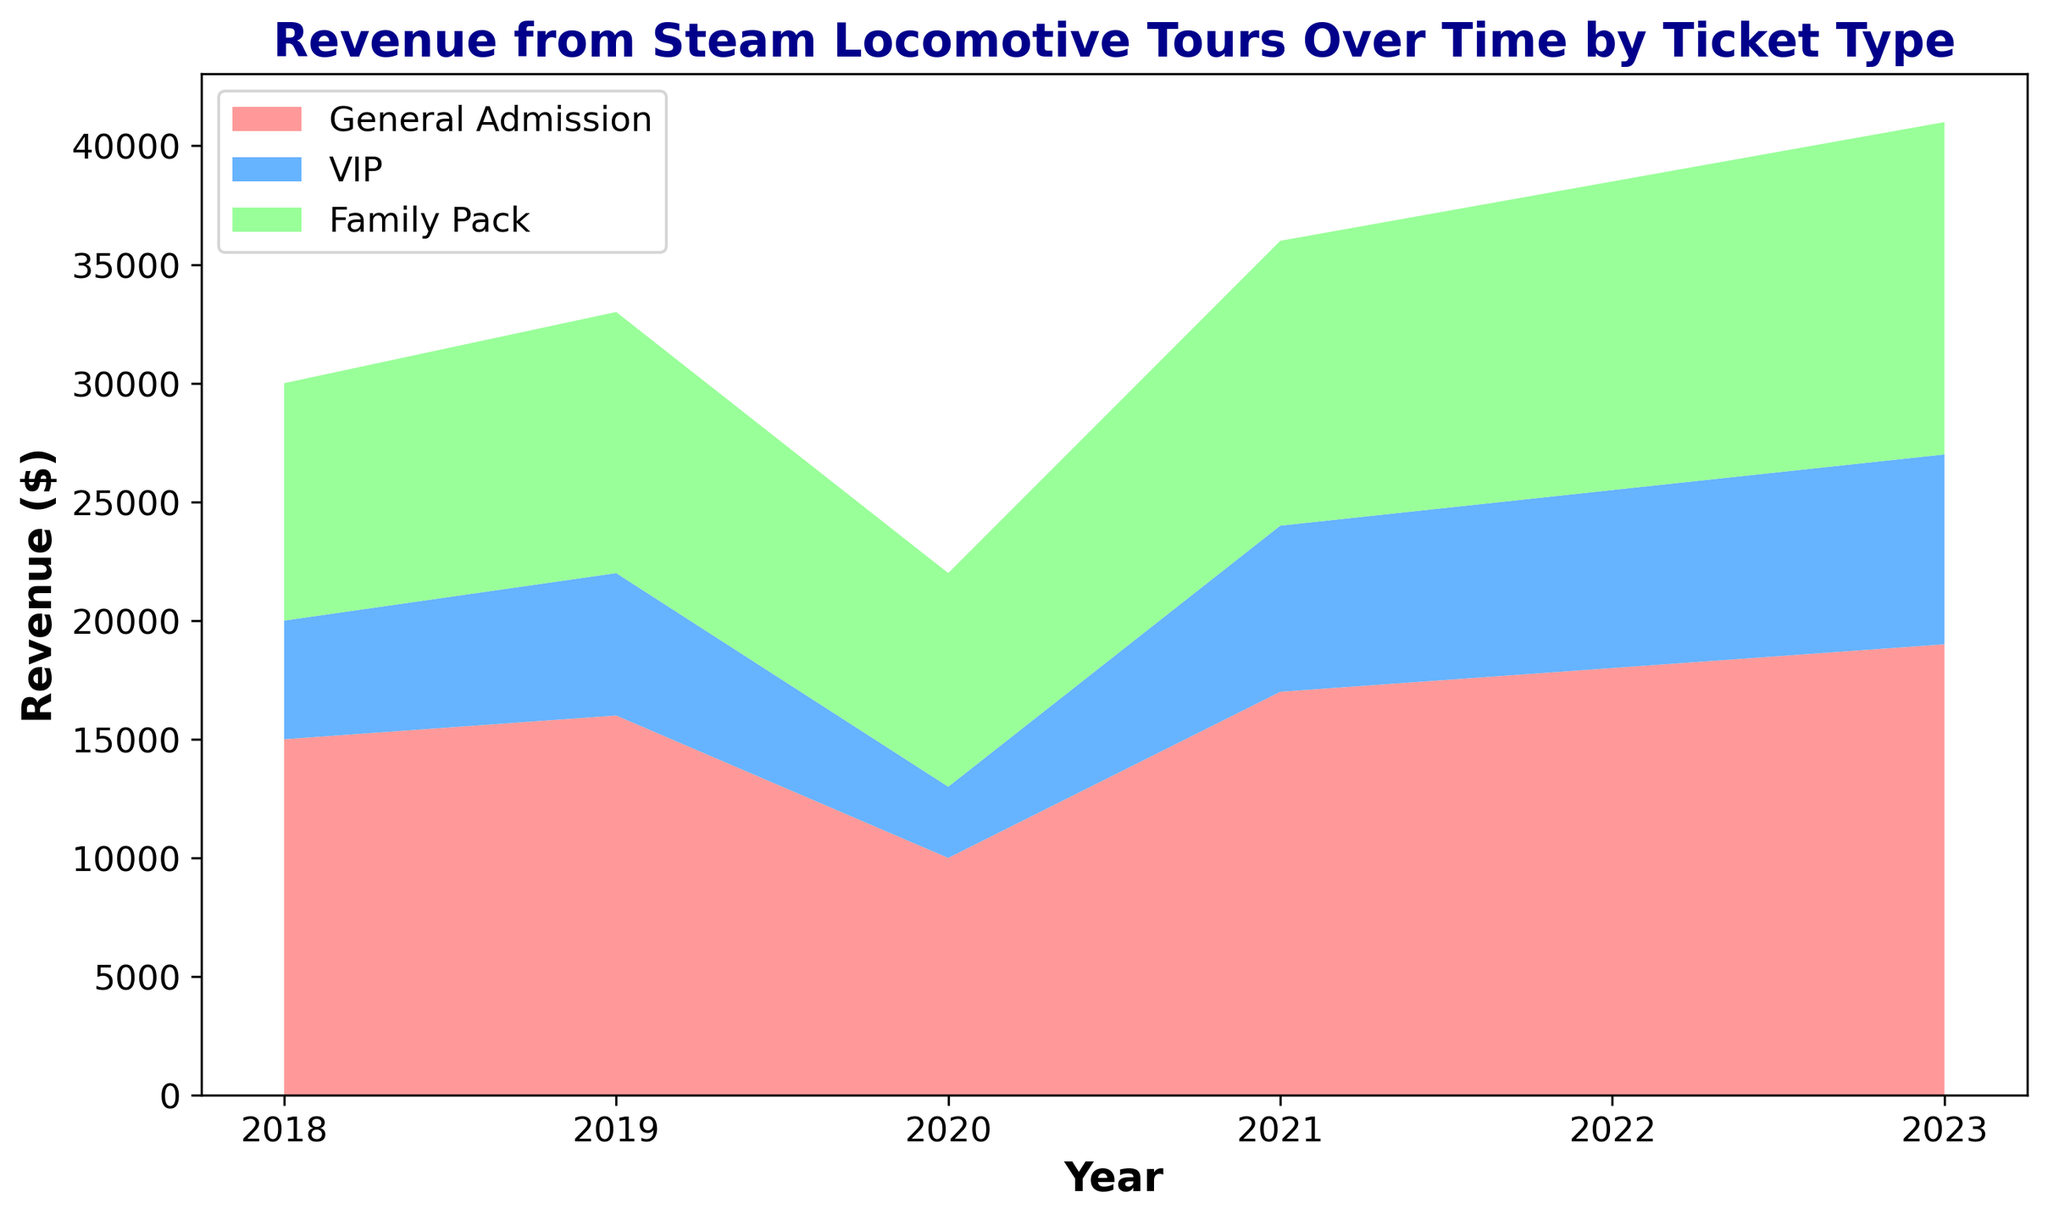What year had the highest revenue from General Admission tickets? The chart shows the revenue from General Admission tickets over the years. The highest point is in 2023.
Answer: 2023 How much more revenue did VIP tickets generate in 2023 compared to 2020? In 2023, VIP tickets generated $8000, and in 2020, they generated $3000. The difference is $8000 - $3000 = $5000.
Answer: $5000 Compare the Family Pack ticket revenues in 2018 and 2022. Which year had a higher revenue, and by how much? In 2018, the Family Pack revenue was $10000, and in 2022, it was $13000. The difference is $13000 - $10000 = $3000.
Answer: 2022, by $3000 Which ticket type showed the most significant increase in revenue from 2019 to 2021? The revenues for each ticket type from 2019 to 2021 are as follows: General Admission increased from $16000 to $17000 ($1000 increase), VIP increased from $6000 to $7000 ($1000 increase), and Family Pack increased from $11000 to $12000 ($1000 increase). Each ticket type showed the same increase of $1000.
Answer: All had the same increase of $1000 What's the total revenue from all ticket types in 2023? Sum the revenues from all ticket types in 2023: General Admission ($19000) + VIP ($8000) + Family Pack ($14000) = $41000.
Answer: $41000 How did the revenue from VIP tickets change between 2018 and 2023? In 2018, VIP ticket revenue was $5000, and in 2023, it was $8000. The change is $8000 - $5000 = $3000 increase.
Answer: Increased by $3000 Which ticket type contributed the least to total revenue in 2021? In 2021, the revenues were: General Admission ($17000), VIP ($7000), Family Pack ($12000). VIP had the lowest revenue.
Answer: VIP What is the average revenue from General Admission tickets over the given years? Sum of revenues from General Admission: 15000 + 16000 + 10000 + 17000 + 18000 + 19000 = 95000. Average = 95000 / 6 ≈ 15833.33.
Answer: $15833.33 Visually, which ticket type shows the steadiest growth over the years? General Admission and Family Pack show steady growth without sharp declines.
Answer: General Admission and Family Pack Between 2020 and 2021, which ticket type had the greatest percentage increase in revenue? Calculate revenue increase for each type from 2020 to 2021: 
General Admission: (17000 - 10000)/10000 = 0.7 or 70%
VIP: (7000 - 3000)/3000 = 1.33 or 133%
Family Pack: (12000 - 9000)/9000 = 0.33 or 33%
The greatest percentage increase is for VIP tickets at 133%.
Answer: VIP 